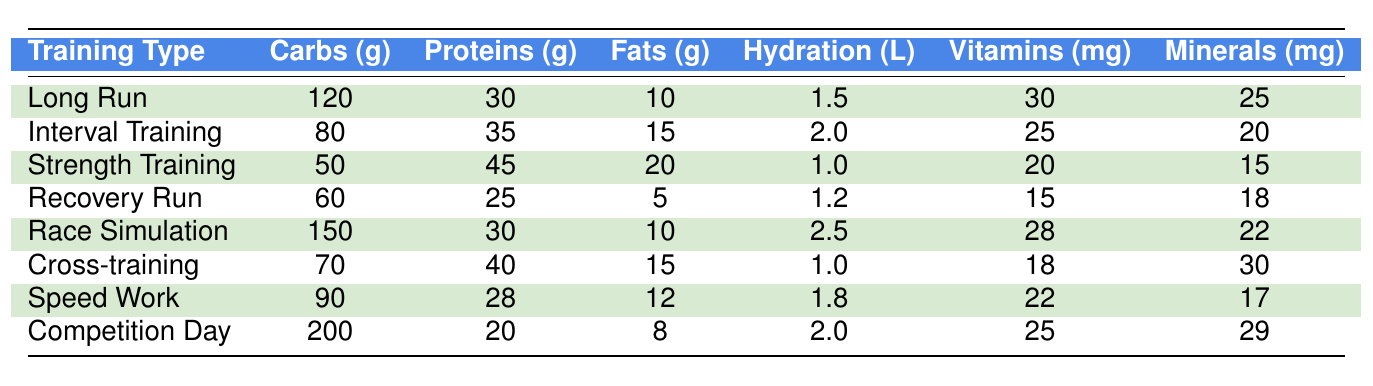What was the carbohydrate intake during the Long Run? The table shows that the carbohydrate intake for the Long Run is listed as 120 grams.
Answer: 120 grams How much protein did the athlete consume on the Race Simulation day? The protein intake on Race Simulation day is found in the table, which indicates it was 30 grams.
Answer: 30 grams What is the total fat intake on Competition Day compared to Strength Training? The fat intake on Competition Day is 8 grams and on Strength Training it is 20 grams. The total is 8 + 20 = 28 grams.
Answer: 28 grams Which training type had the highest hydration level, and what was it? By reviewing the hydration levels in the table, Race Simulation has the highest hydration level of 2.5 liters.
Answer: Race Simulation, 2.5 liters What are the average carbohydrates consumed among the athletes during all training types listed? The total carbohydrates consumed across all training types are (120 + 80 + 50 + 60 + 150 + 70 + 90 + 200) = 820 grams. Dividing by the number of training types (8), the average carbohydrate intake is 820 / 8 = 102.5 grams.
Answer: 102.5 grams Did any athlete consume more than 40 grams of proteins during their training? By checking the protein values in the table, it is observed that Strength Training (45 grams) and Cross-training (40 grams) meet this criterion. Thus, the answer is yes.
Answer: Yes What was the difference in vitamins intake between Long Run and Recovery Run? The vitamins intake for Long Run is 30 mg and for Recovery Run is 15 mg. The difference is 30 - 15 = 15 mg.
Answer: 15 mg On average, how much are minerals consumed during Competition Day compared to Race Simulation? The minerals intake on Competition Day is 29 mg, while it is 22 mg for Race Simulation. The average is (29 + 22) / 2 = 25.5 mg.
Answer: 25.5 mg Which training type had the lowest fat intake and what was it? The table shows that the Recovery Run had the lowest fat intake of 5 grams.
Answer: Recovery Run, 5 grams Is the protein intake on Competition Day less than on Long Run day? The protein intake on Competition Day is 20 grams, while on Long Run it is 30 grams. Since 20 is less than 30, the answer is yes.
Answer: Yes 